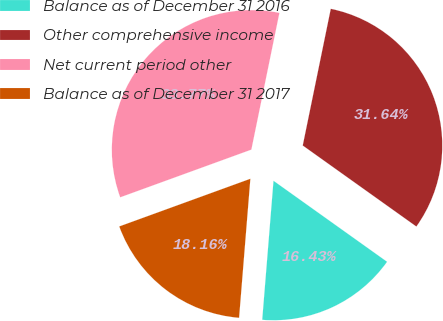Convert chart. <chart><loc_0><loc_0><loc_500><loc_500><pie_chart><fcel>Balance as of December 31 2016<fcel>Other comprehensive income<fcel>Net current period other<fcel>Balance as of December 31 2017<nl><fcel>16.43%<fcel>31.64%<fcel>33.77%<fcel>18.16%<nl></chart> 